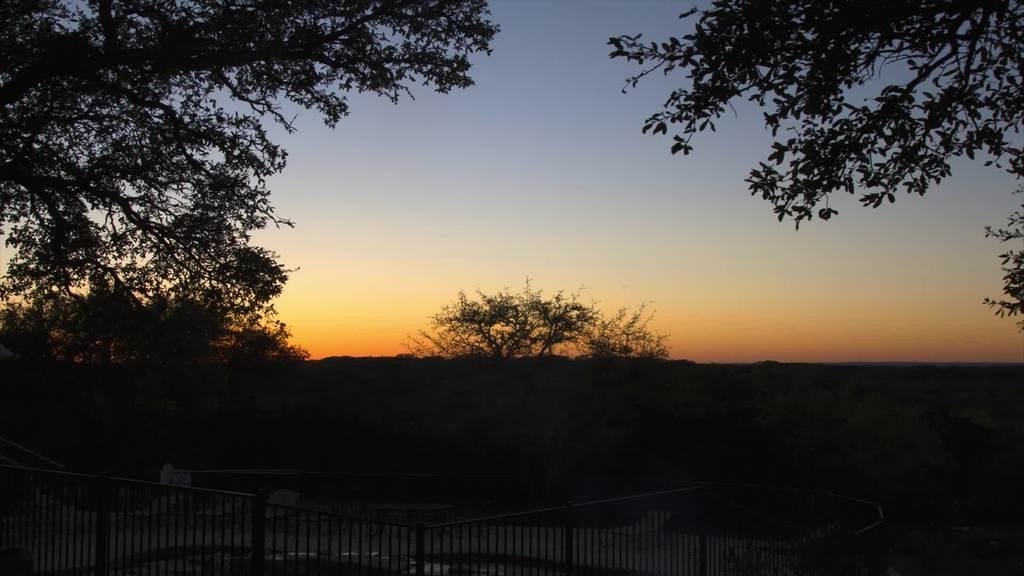Describe this image in one or two sentences. In this image we can see an iron railing, few trees and sky in the background. 